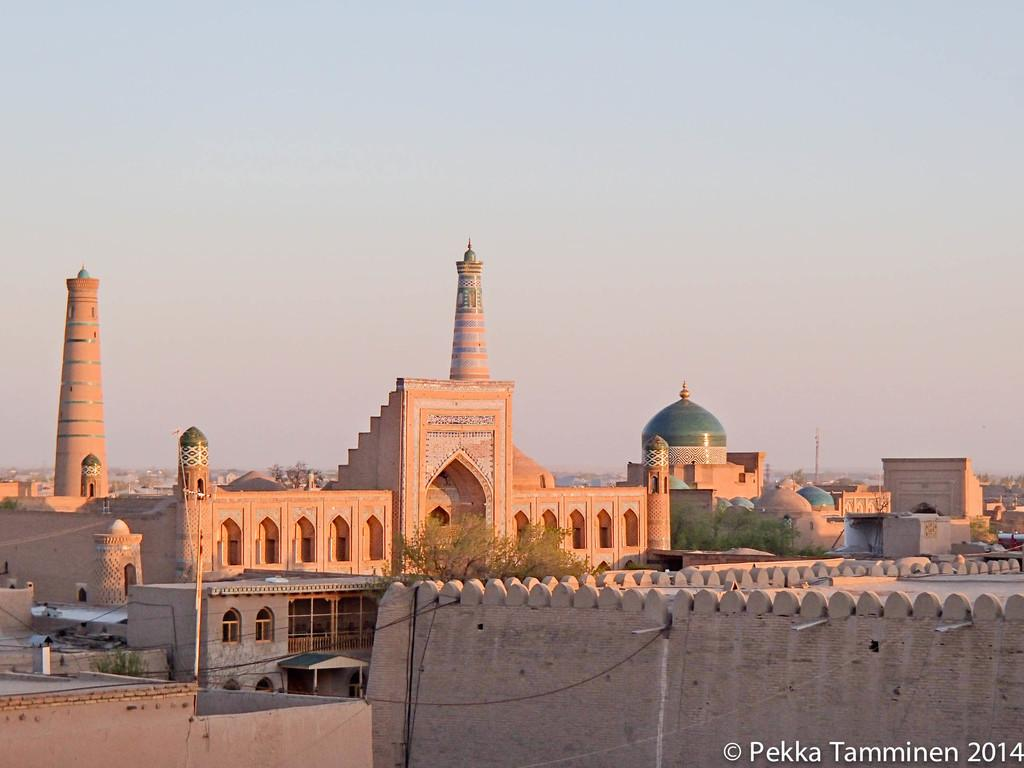What type of structures can be seen in the image? There are buildings in the image. What other natural elements are present in the image? There are trees in the image. Are there any man-made objects visible in the image? Yes, there are wires in the image. Can you describe any additional features of the image? There is a watermark in the image. How many lamps are hanging from the trees in the image? There are no lamps present in the image; it features buildings, trees, wires, and a watermark. What direction does the hope take in the image? The concept of hope is not a physical object or element that can be observed in the image. 